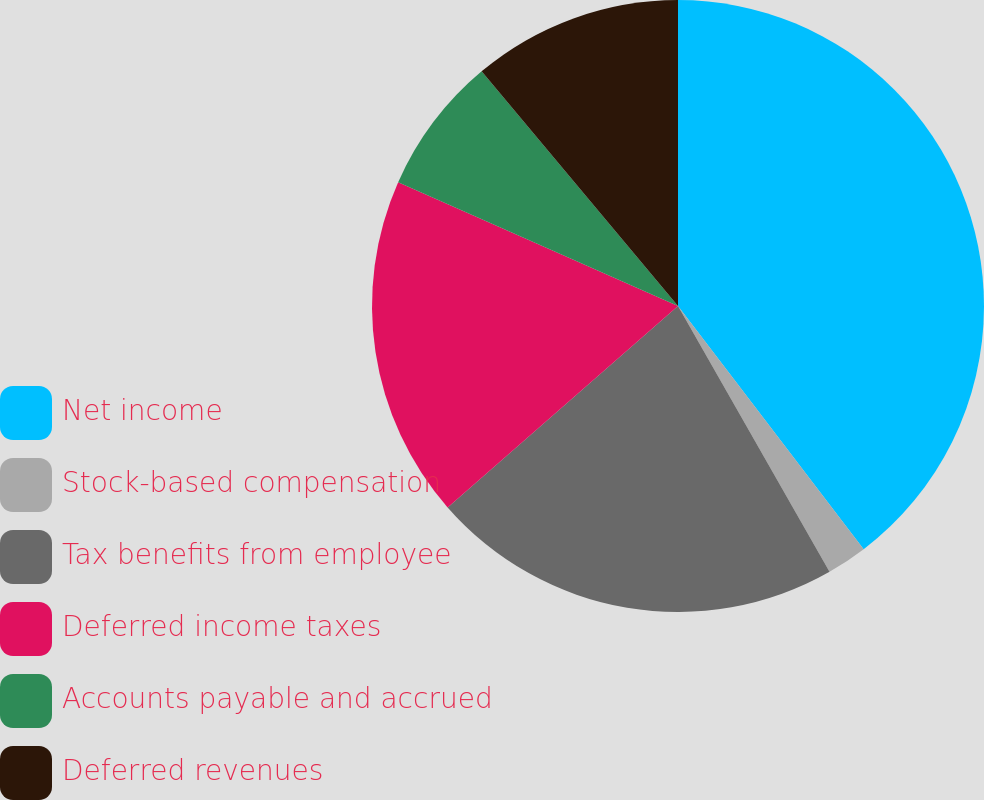Convert chart. <chart><loc_0><loc_0><loc_500><loc_500><pie_chart><fcel>Net income<fcel>Stock-based compensation<fcel>Tax benefits from employee<fcel>Deferred income taxes<fcel>Accounts payable and accrued<fcel>Deferred revenues<nl><fcel>39.62%<fcel>2.13%<fcel>21.81%<fcel>18.06%<fcel>7.28%<fcel>11.09%<nl></chart> 